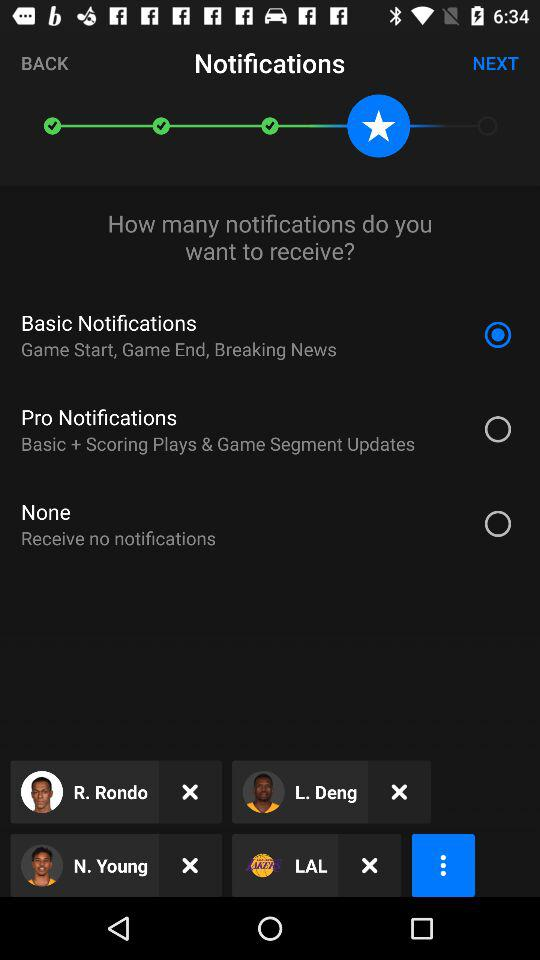Which kind of information receive from notifications?
When the provided information is insufficient, respond with <no answer>. <no answer> 